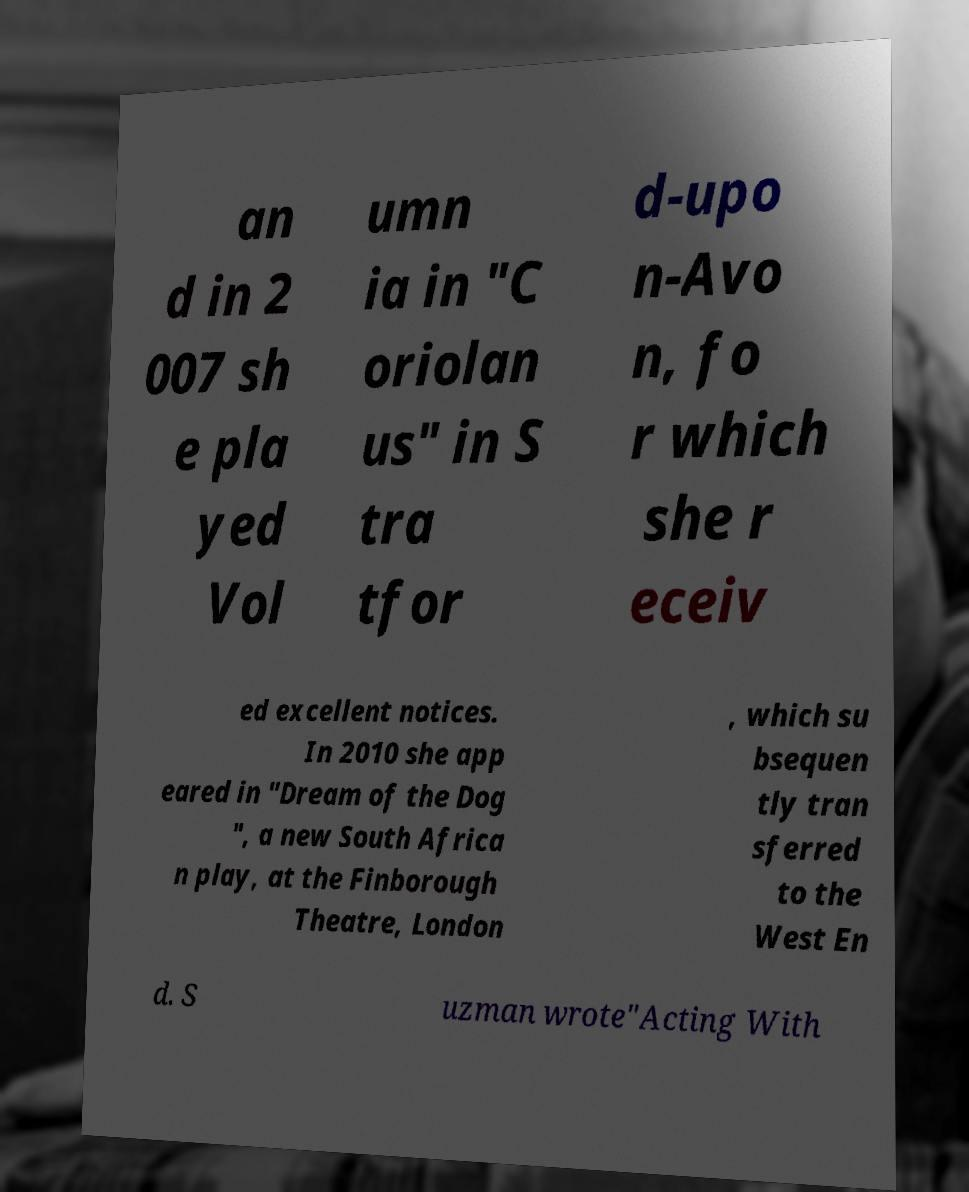For documentation purposes, I need the text within this image transcribed. Could you provide that? an d in 2 007 sh e pla yed Vol umn ia in "C oriolan us" in S tra tfor d-upo n-Avo n, fo r which she r eceiv ed excellent notices. In 2010 she app eared in "Dream of the Dog ", a new South Africa n play, at the Finborough Theatre, London , which su bsequen tly tran sferred to the West En d. S uzman wrote"Acting With 